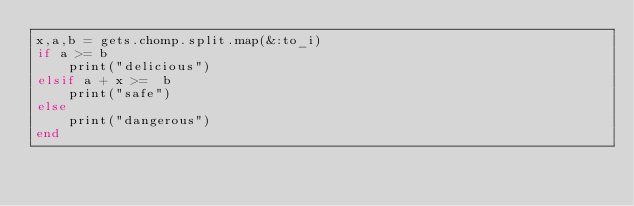Convert code to text. <code><loc_0><loc_0><loc_500><loc_500><_Ruby_>x,a,b = gets.chomp.split.map(&:to_i)
if a >= b
    print("delicious")
elsif a + x >=  b
    print("safe")
else
    print("dangerous")
end


</code> 